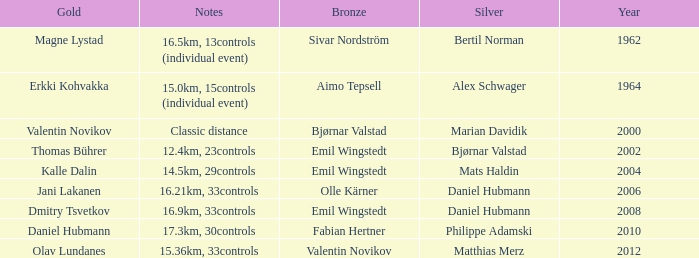WHAT IS THE SILVER WITH A YEAR OF 1962? Bertil Norman. 